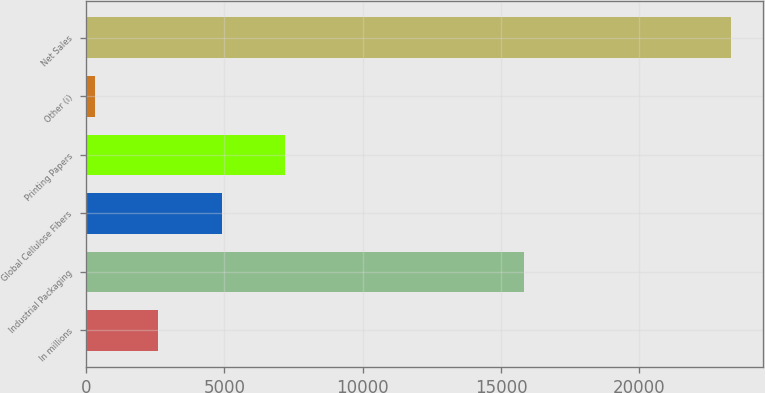<chart> <loc_0><loc_0><loc_500><loc_500><bar_chart><fcel>In millions<fcel>Industrial Packaging<fcel>Global Cellulose Fibers<fcel>Printing Papers<fcel>Other (i)<fcel>Net Sales<nl><fcel>2608.7<fcel>15828<fcel>4908.4<fcel>7208.1<fcel>309<fcel>23306<nl></chart> 